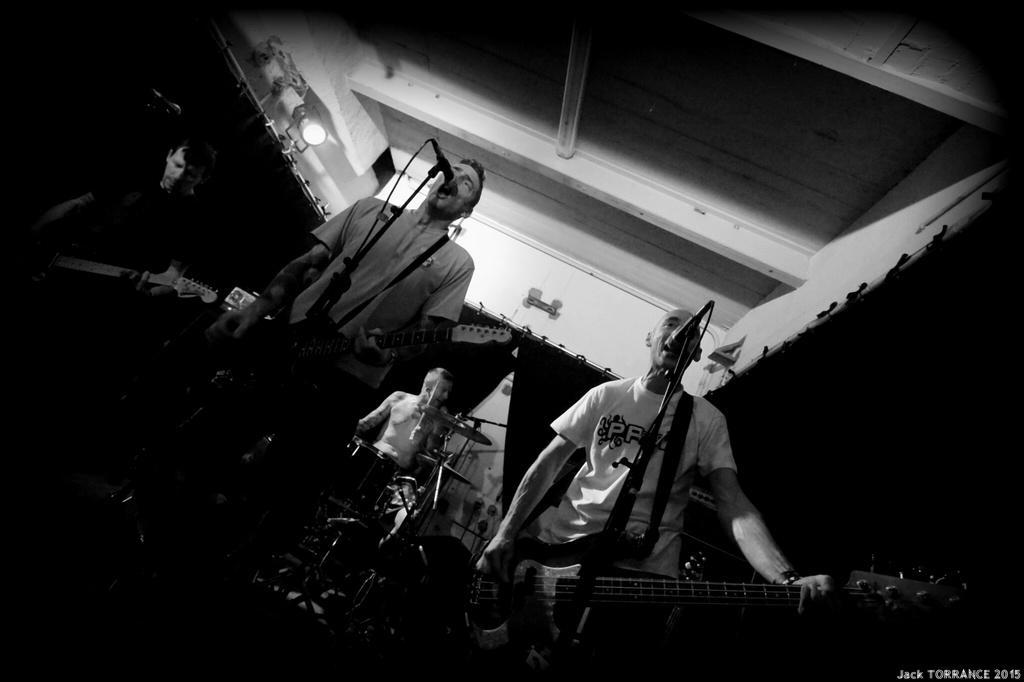How would you summarize this image in a sentence or two? In this picture we can see four people, they are all musicians they are playing musical instruments in front of microphone. In the background we can see some curtains and lights. 